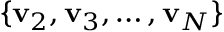<formula> <loc_0><loc_0><loc_500><loc_500>\{ v _ { 2 } , v _ { 3 } , \dots , v _ { N } \}</formula> 